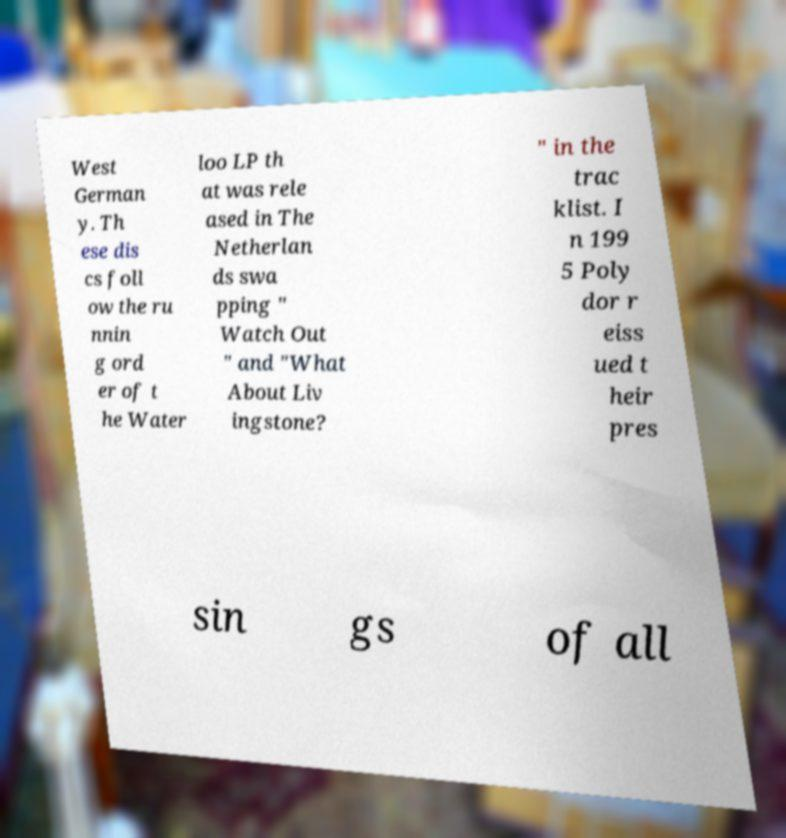For documentation purposes, I need the text within this image transcribed. Could you provide that? West German y. Th ese dis cs foll ow the ru nnin g ord er of t he Water loo LP th at was rele ased in The Netherlan ds swa pping " Watch Out " and "What About Liv ingstone? " in the trac klist. I n 199 5 Poly dor r eiss ued t heir pres sin gs of all 